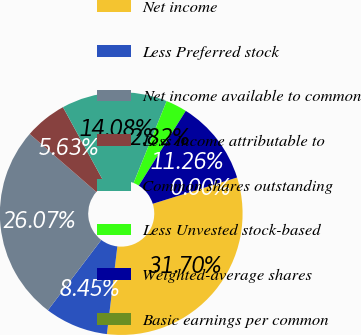<chart> <loc_0><loc_0><loc_500><loc_500><pie_chart><fcel>Net income<fcel>Less Preferred stock<fcel>Net income available to common<fcel>Less Income attributable to<fcel>Common shares outstanding<fcel>Less Unvested stock-based<fcel>Weighted-average shares<fcel>Basic earnings per common<nl><fcel>31.7%<fcel>8.45%<fcel>26.07%<fcel>5.63%<fcel>14.08%<fcel>2.82%<fcel>11.26%<fcel>0.0%<nl></chart> 